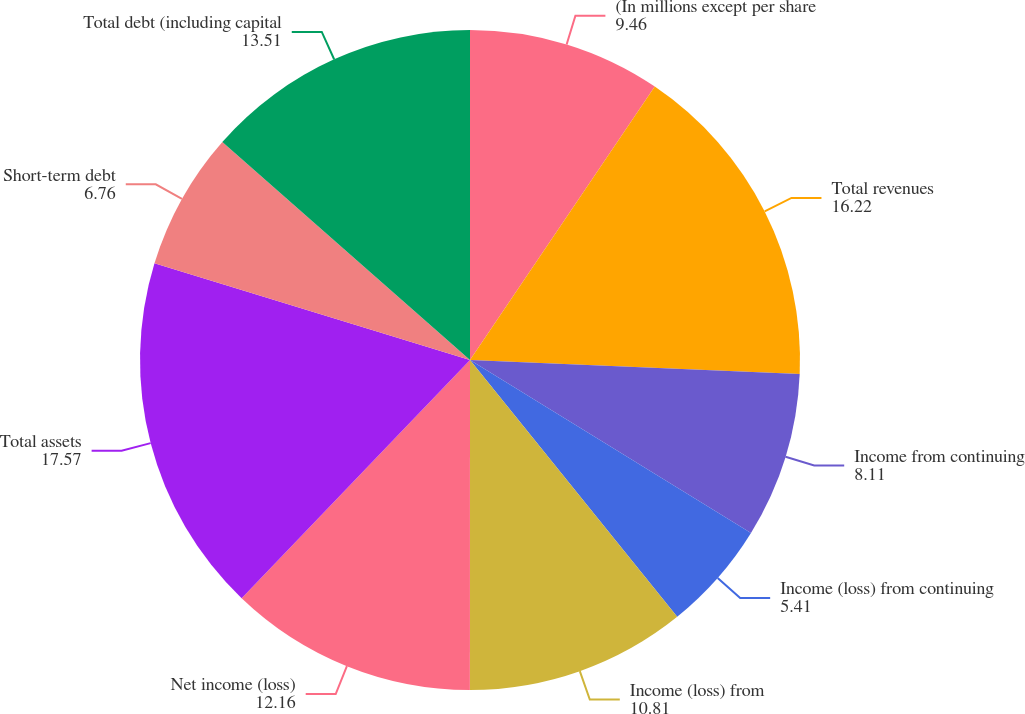<chart> <loc_0><loc_0><loc_500><loc_500><pie_chart><fcel>(In millions except per share<fcel>Total revenues<fcel>Income from continuing<fcel>Income (loss) from continuing<fcel>Income (loss) from<fcel>Net income (loss)<fcel>Total assets<fcel>Short-term debt<fcel>Total debt (including capital<nl><fcel>9.46%<fcel>16.22%<fcel>8.11%<fcel>5.41%<fcel>10.81%<fcel>12.16%<fcel>17.57%<fcel>6.76%<fcel>13.51%<nl></chart> 